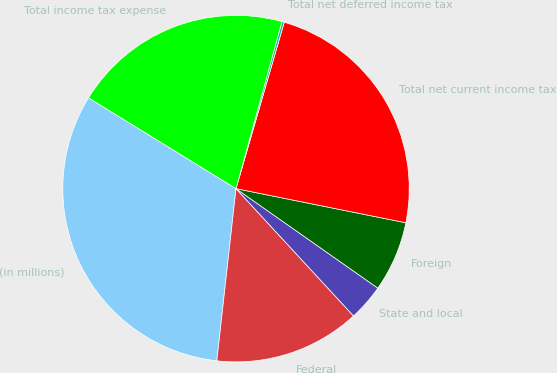<chart> <loc_0><loc_0><loc_500><loc_500><pie_chart><fcel>(in millions)<fcel>Federal<fcel>State and local<fcel>Foreign<fcel>Total net current income tax<fcel>Total net deferred income tax<fcel>Total income tax expense<nl><fcel>32.02%<fcel>13.63%<fcel>3.4%<fcel>6.58%<fcel>23.67%<fcel>0.22%<fcel>20.49%<nl></chart> 